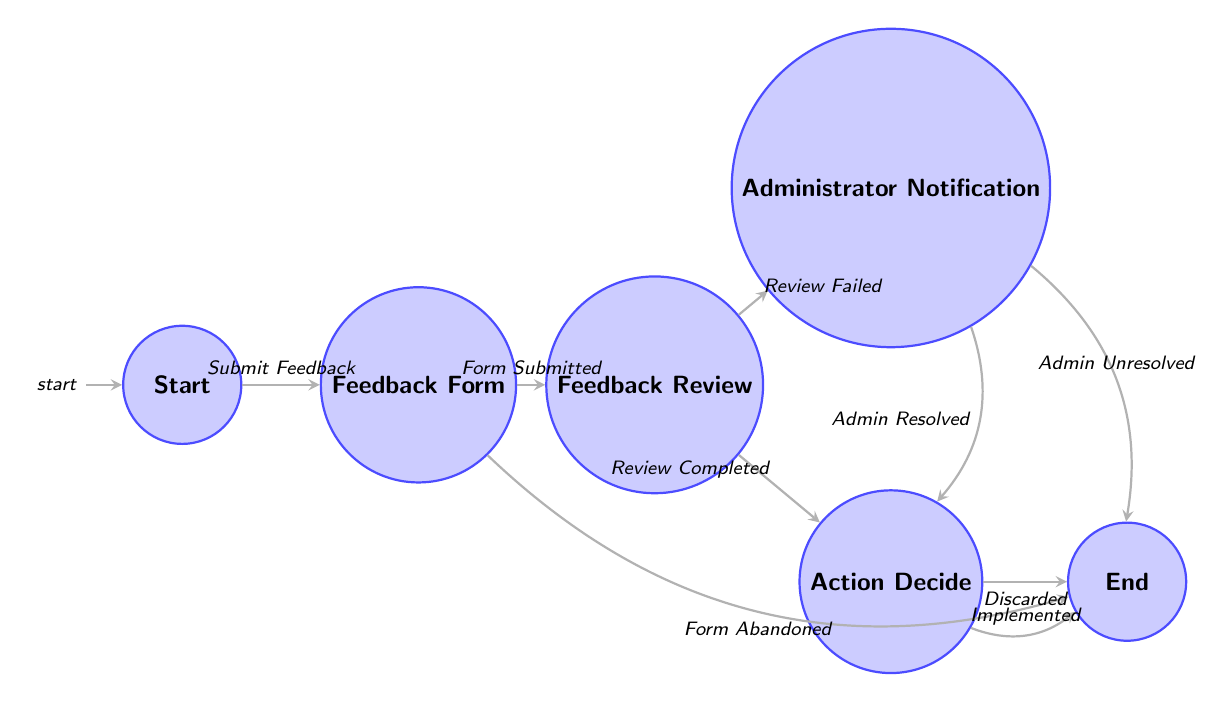What's the initial state of the diagram? The initial state is indicated by the "initial" label on the "Start" node.
Answer: Start How many nodes are in the diagram? The diagram contains six states: Start, Feedback Form, Feedback Review, Action Decide, Administrator Notification, and End.
Answer: 6 What is the transition from "Feedback Form" to "Feedback Review"? The transition that leads from "Feedback Form" to "Feedback Review" is labeled "Form Submitted".
Answer: Form Submitted Which two nodes can be reached directly from "Feedback Review"? The two nodes that can be reached directly from "Feedback Review" are "Action Decide" and "Administrator Notification".
Answer: Action Decide, Administrator Notification What happens if the feedback form is abandoned? If the feedback form is abandoned, the diagram shows a transition to the "End" state.
Answer: End If the review of feedback fails, what is the next state? The next state after a failed review is "Administrator Notification," as indicated by the edge labeled "Review Failed".
Answer: Administrator Notification What happens after an administrator resolves the issue? After an administrator resolves the issue, the flow transitions to "Action Decide".
Answer: Action Decide What are the two possible outcomes in the "Action Decide" state? The two possible outcomes in "Action Decide" are "Implemented" and "Discarded", leading to the "End" state.
Answer: Implemented, Discarded In which state does the process end if the administrator is unresolved? If the administrator is unresolved, the process ends in the "End" state, as shown by the transition labeled "Admin Unresolved".
Answer: End 